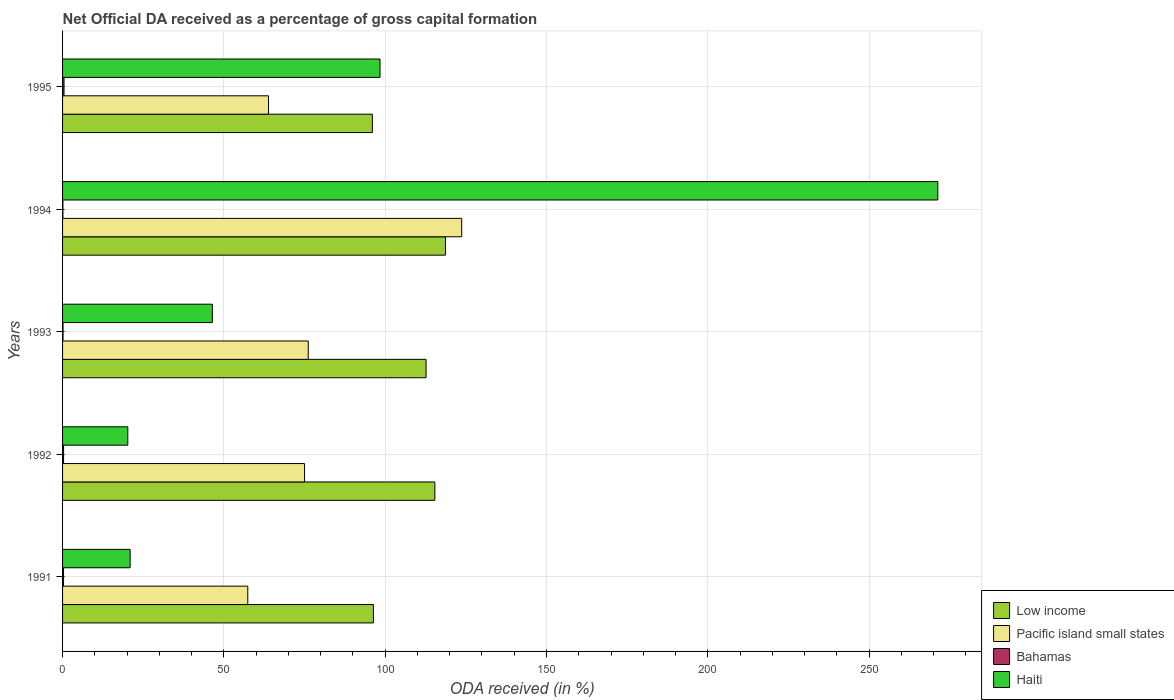How many different coloured bars are there?
Provide a short and direct response. 4. Are the number of bars per tick equal to the number of legend labels?
Your answer should be compact. Yes. How many bars are there on the 1st tick from the top?
Provide a succinct answer. 4. What is the label of the 5th group of bars from the top?
Offer a terse response. 1991. In how many cases, is the number of bars for a given year not equal to the number of legend labels?
Provide a succinct answer. 0. What is the net ODA received in Haiti in 1994?
Provide a succinct answer. 271.29. Across all years, what is the maximum net ODA received in Bahamas?
Your answer should be very brief. 0.45. Across all years, what is the minimum net ODA received in Low income?
Keep it short and to the point. 96.03. In which year was the net ODA received in Bahamas maximum?
Your response must be concise. 1995. What is the total net ODA received in Pacific island small states in the graph?
Provide a short and direct response. 396.11. What is the difference between the net ODA received in Bahamas in 1991 and that in 1992?
Provide a succinct answer. -0.01. What is the difference between the net ODA received in Low income in 1993 and the net ODA received in Haiti in 1995?
Ensure brevity in your answer.  14.27. What is the average net ODA received in Haiti per year?
Make the answer very short. 91.46. In the year 1993, what is the difference between the net ODA received in Low income and net ODA received in Bahamas?
Make the answer very short. 112.53. In how many years, is the net ODA received in Haiti greater than 100 %?
Keep it short and to the point. 1. What is the ratio of the net ODA received in Pacific island small states in 1993 to that in 1994?
Give a very brief answer. 0.62. What is the difference between the highest and the second highest net ODA received in Haiti?
Provide a succinct answer. 172.9. What is the difference between the highest and the lowest net ODA received in Low income?
Your answer should be very brief. 22.66. In how many years, is the net ODA received in Pacific island small states greater than the average net ODA received in Pacific island small states taken over all years?
Provide a short and direct response. 1. What does the 4th bar from the top in 1992 represents?
Keep it short and to the point. Low income. What does the 3rd bar from the bottom in 1991 represents?
Ensure brevity in your answer.  Bahamas. How many bars are there?
Your answer should be very brief. 20. How many years are there in the graph?
Your answer should be compact. 5. What is the difference between two consecutive major ticks on the X-axis?
Your answer should be very brief. 50. Are the values on the major ticks of X-axis written in scientific E-notation?
Offer a terse response. No. How many legend labels are there?
Keep it short and to the point. 4. How are the legend labels stacked?
Your response must be concise. Vertical. What is the title of the graph?
Provide a short and direct response. Net Official DA received as a percentage of gross capital formation. What is the label or title of the X-axis?
Your answer should be compact. ODA received (in %). What is the label or title of the Y-axis?
Give a very brief answer. Years. What is the ODA received (in %) in Low income in 1991?
Offer a terse response. 96.34. What is the ODA received (in %) in Pacific island small states in 1991?
Ensure brevity in your answer.  57.41. What is the ODA received (in %) in Bahamas in 1991?
Ensure brevity in your answer.  0.3. What is the ODA received (in %) of Haiti in 1991?
Provide a short and direct response. 20.95. What is the ODA received (in %) of Low income in 1992?
Offer a very short reply. 115.4. What is the ODA received (in %) in Pacific island small states in 1992?
Provide a short and direct response. 75. What is the ODA received (in %) in Bahamas in 1992?
Your answer should be compact. 0.31. What is the ODA received (in %) in Haiti in 1992?
Offer a terse response. 20.23. What is the ODA received (in %) in Low income in 1993?
Offer a very short reply. 112.67. What is the ODA received (in %) in Pacific island small states in 1993?
Keep it short and to the point. 76.15. What is the ODA received (in %) of Bahamas in 1993?
Your answer should be very brief. 0.14. What is the ODA received (in %) of Haiti in 1993?
Ensure brevity in your answer.  46.42. What is the ODA received (in %) in Low income in 1994?
Offer a terse response. 118.68. What is the ODA received (in %) of Pacific island small states in 1994?
Your answer should be very brief. 123.71. What is the ODA received (in %) in Bahamas in 1994?
Provide a succinct answer. 0.1. What is the ODA received (in %) of Haiti in 1994?
Your answer should be very brief. 271.29. What is the ODA received (in %) in Low income in 1995?
Your answer should be very brief. 96.03. What is the ODA received (in %) in Pacific island small states in 1995?
Ensure brevity in your answer.  63.84. What is the ODA received (in %) of Bahamas in 1995?
Your response must be concise. 0.45. What is the ODA received (in %) of Haiti in 1995?
Your response must be concise. 98.4. Across all years, what is the maximum ODA received (in %) in Low income?
Provide a succinct answer. 118.68. Across all years, what is the maximum ODA received (in %) of Pacific island small states?
Your answer should be compact. 123.71. Across all years, what is the maximum ODA received (in %) in Bahamas?
Provide a short and direct response. 0.45. Across all years, what is the maximum ODA received (in %) of Haiti?
Keep it short and to the point. 271.29. Across all years, what is the minimum ODA received (in %) of Low income?
Your response must be concise. 96.03. Across all years, what is the minimum ODA received (in %) in Pacific island small states?
Give a very brief answer. 57.41. Across all years, what is the minimum ODA received (in %) in Bahamas?
Your answer should be compact. 0.1. Across all years, what is the minimum ODA received (in %) in Haiti?
Provide a short and direct response. 20.23. What is the total ODA received (in %) in Low income in the graph?
Provide a short and direct response. 539.12. What is the total ODA received (in %) in Pacific island small states in the graph?
Provide a succinct answer. 396.11. What is the total ODA received (in %) of Bahamas in the graph?
Give a very brief answer. 1.31. What is the total ODA received (in %) of Haiti in the graph?
Your answer should be compact. 457.28. What is the difference between the ODA received (in %) of Low income in 1991 and that in 1992?
Provide a short and direct response. -19.05. What is the difference between the ODA received (in %) of Pacific island small states in 1991 and that in 1992?
Give a very brief answer. -17.59. What is the difference between the ODA received (in %) of Bahamas in 1991 and that in 1992?
Offer a terse response. -0.01. What is the difference between the ODA received (in %) of Haiti in 1991 and that in 1992?
Make the answer very short. 0.72. What is the difference between the ODA received (in %) of Low income in 1991 and that in 1993?
Offer a very short reply. -16.33. What is the difference between the ODA received (in %) in Pacific island small states in 1991 and that in 1993?
Give a very brief answer. -18.74. What is the difference between the ODA received (in %) of Bahamas in 1991 and that in 1993?
Provide a succinct answer. 0.16. What is the difference between the ODA received (in %) of Haiti in 1991 and that in 1993?
Your response must be concise. -25.48. What is the difference between the ODA received (in %) of Low income in 1991 and that in 1994?
Your response must be concise. -22.34. What is the difference between the ODA received (in %) of Pacific island small states in 1991 and that in 1994?
Make the answer very short. -66.3. What is the difference between the ODA received (in %) of Bahamas in 1991 and that in 1994?
Your answer should be very brief. 0.2. What is the difference between the ODA received (in %) of Haiti in 1991 and that in 1994?
Offer a very short reply. -250.35. What is the difference between the ODA received (in %) of Low income in 1991 and that in 1995?
Offer a very short reply. 0.32. What is the difference between the ODA received (in %) of Pacific island small states in 1991 and that in 1995?
Offer a terse response. -6.43. What is the difference between the ODA received (in %) in Bahamas in 1991 and that in 1995?
Provide a short and direct response. -0.15. What is the difference between the ODA received (in %) of Haiti in 1991 and that in 1995?
Give a very brief answer. -77.45. What is the difference between the ODA received (in %) of Low income in 1992 and that in 1993?
Offer a very short reply. 2.72. What is the difference between the ODA received (in %) in Pacific island small states in 1992 and that in 1993?
Provide a succinct answer. -1.15. What is the difference between the ODA received (in %) in Bahamas in 1992 and that in 1993?
Provide a succinct answer. 0.17. What is the difference between the ODA received (in %) of Haiti in 1992 and that in 1993?
Provide a short and direct response. -26.2. What is the difference between the ODA received (in %) in Low income in 1992 and that in 1994?
Offer a terse response. -3.29. What is the difference between the ODA received (in %) in Pacific island small states in 1992 and that in 1994?
Keep it short and to the point. -48.71. What is the difference between the ODA received (in %) in Bahamas in 1992 and that in 1994?
Ensure brevity in your answer.  0.21. What is the difference between the ODA received (in %) of Haiti in 1992 and that in 1994?
Your answer should be very brief. -251.07. What is the difference between the ODA received (in %) of Low income in 1992 and that in 1995?
Offer a terse response. 19.37. What is the difference between the ODA received (in %) in Pacific island small states in 1992 and that in 1995?
Ensure brevity in your answer.  11.16. What is the difference between the ODA received (in %) of Bahamas in 1992 and that in 1995?
Offer a terse response. -0.14. What is the difference between the ODA received (in %) in Haiti in 1992 and that in 1995?
Keep it short and to the point. -78.17. What is the difference between the ODA received (in %) of Low income in 1993 and that in 1994?
Your answer should be very brief. -6.01. What is the difference between the ODA received (in %) in Pacific island small states in 1993 and that in 1994?
Make the answer very short. -47.56. What is the difference between the ODA received (in %) of Bahamas in 1993 and that in 1994?
Offer a terse response. 0.04. What is the difference between the ODA received (in %) of Haiti in 1993 and that in 1994?
Provide a succinct answer. -224.87. What is the difference between the ODA received (in %) in Low income in 1993 and that in 1995?
Your answer should be very brief. 16.64. What is the difference between the ODA received (in %) of Pacific island small states in 1993 and that in 1995?
Make the answer very short. 12.31. What is the difference between the ODA received (in %) of Bahamas in 1993 and that in 1995?
Give a very brief answer. -0.31. What is the difference between the ODA received (in %) of Haiti in 1993 and that in 1995?
Keep it short and to the point. -51.98. What is the difference between the ODA received (in %) of Low income in 1994 and that in 1995?
Keep it short and to the point. 22.66. What is the difference between the ODA received (in %) in Pacific island small states in 1994 and that in 1995?
Offer a very short reply. 59.87. What is the difference between the ODA received (in %) in Bahamas in 1994 and that in 1995?
Offer a very short reply. -0.35. What is the difference between the ODA received (in %) of Haiti in 1994 and that in 1995?
Give a very brief answer. 172.9. What is the difference between the ODA received (in %) of Low income in 1991 and the ODA received (in %) of Pacific island small states in 1992?
Your answer should be very brief. 21.34. What is the difference between the ODA received (in %) of Low income in 1991 and the ODA received (in %) of Bahamas in 1992?
Your response must be concise. 96.03. What is the difference between the ODA received (in %) of Low income in 1991 and the ODA received (in %) of Haiti in 1992?
Give a very brief answer. 76.12. What is the difference between the ODA received (in %) of Pacific island small states in 1991 and the ODA received (in %) of Bahamas in 1992?
Your response must be concise. 57.1. What is the difference between the ODA received (in %) in Pacific island small states in 1991 and the ODA received (in %) in Haiti in 1992?
Give a very brief answer. 37.18. What is the difference between the ODA received (in %) of Bahamas in 1991 and the ODA received (in %) of Haiti in 1992?
Offer a very short reply. -19.92. What is the difference between the ODA received (in %) in Low income in 1991 and the ODA received (in %) in Pacific island small states in 1993?
Give a very brief answer. 20.2. What is the difference between the ODA received (in %) of Low income in 1991 and the ODA received (in %) of Bahamas in 1993?
Provide a short and direct response. 96.2. What is the difference between the ODA received (in %) in Low income in 1991 and the ODA received (in %) in Haiti in 1993?
Offer a very short reply. 49.92. What is the difference between the ODA received (in %) in Pacific island small states in 1991 and the ODA received (in %) in Bahamas in 1993?
Make the answer very short. 57.27. What is the difference between the ODA received (in %) of Pacific island small states in 1991 and the ODA received (in %) of Haiti in 1993?
Your answer should be compact. 10.99. What is the difference between the ODA received (in %) in Bahamas in 1991 and the ODA received (in %) in Haiti in 1993?
Make the answer very short. -46.12. What is the difference between the ODA received (in %) of Low income in 1991 and the ODA received (in %) of Pacific island small states in 1994?
Give a very brief answer. -27.37. What is the difference between the ODA received (in %) of Low income in 1991 and the ODA received (in %) of Bahamas in 1994?
Your answer should be compact. 96.24. What is the difference between the ODA received (in %) of Low income in 1991 and the ODA received (in %) of Haiti in 1994?
Your answer should be compact. -174.95. What is the difference between the ODA received (in %) of Pacific island small states in 1991 and the ODA received (in %) of Bahamas in 1994?
Make the answer very short. 57.31. What is the difference between the ODA received (in %) in Pacific island small states in 1991 and the ODA received (in %) in Haiti in 1994?
Provide a succinct answer. -213.88. What is the difference between the ODA received (in %) of Bahamas in 1991 and the ODA received (in %) of Haiti in 1994?
Your response must be concise. -270.99. What is the difference between the ODA received (in %) of Low income in 1991 and the ODA received (in %) of Pacific island small states in 1995?
Keep it short and to the point. 32.5. What is the difference between the ODA received (in %) of Low income in 1991 and the ODA received (in %) of Bahamas in 1995?
Give a very brief answer. 95.89. What is the difference between the ODA received (in %) of Low income in 1991 and the ODA received (in %) of Haiti in 1995?
Keep it short and to the point. -2.06. What is the difference between the ODA received (in %) of Pacific island small states in 1991 and the ODA received (in %) of Bahamas in 1995?
Provide a short and direct response. 56.96. What is the difference between the ODA received (in %) of Pacific island small states in 1991 and the ODA received (in %) of Haiti in 1995?
Your answer should be compact. -40.99. What is the difference between the ODA received (in %) of Bahamas in 1991 and the ODA received (in %) of Haiti in 1995?
Keep it short and to the point. -98.1. What is the difference between the ODA received (in %) in Low income in 1992 and the ODA received (in %) in Pacific island small states in 1993?
Provide a succinct answer. 39.25. What is the difference between the ODA received (in %) of Low income in 1992 and the ODA received (in %) of Bahamas in 1993?
Offer a terse response. 115.25. What is the difference between the ODA received (in %) in Low income in 1992 and the ODA received (in %) in Haiti in 1993?
Provide a short and direct response. 68.97. What is the difference between the ODA received (in %) in Pacific island small states in 1992 and the ODA received (in %) in Bahamas in 1993?
Provide a succinct answer. 74.86. What is the difference between the ODA received (in %) of Pacific island small states in 1992 and the ODA received (in %) of Haiti in 1993?
Your answer should be very brief. 28.58. What is the difference between the ODA received (in %) in Bahamas in 1992 and the ODA received (in %) in Haiti in 1993?
Your response must be concise. -46.11. What is the difference between the ODA received (in %) of Low income in 1992 and the ODA received (in %) of Pacific island small states in 1994?
Offer a very short reply. -8.31. What is the difference between the ODA received (in %) in Low income in 1992 and the ODA received (in %) in Bahamas in 1994?
Offer a terse response. 115.29. What is the difference between the ODA received (in %) of Low income in 1992 and the ODA received (in %) of Haiti in 1994?
Offer a very short reply. -155.9. What is the difference between the ODA received (in %) in Pacific island small states in 1992 and the ODA received (in %) in Bahamas in 1994?
Offer a terse response. 74.9. What is the difference between the ODA received (in %) of Pacific island small states in 1992 and the ODA received (in %) of Haiti in 1994?
Your response must be concise. -196.29. What is the difference between the ODA received (in %) of Bahamas in 1992 and the ODA received (in %) of Haiti in 1994?
Provide a succinct answer. -270.98. What is the difference between the ODA received (in %) of Low income in 1992 and the ODA received (in %) of Pacific island small states in 1995?
Ensure brevity in your answer.  51.56. What is the difference between the ODA received (in %) of Low income in 1992 and the ODA received (in %) of Bahamas in 1995?
Ensure brevity in your answer.  114.95. What is the difference between the ODA received (in %) of Low income in 1992 and the ODA received (in %) of Haiti in 1995?
Your response must be concise. 17. What is the difference between the ODA received (in %) of Pacific island small states in 1992 and the ODA received (in %) of Bahamas in 1995?
Provide a succinct answer. 74.55. What is the difference between the ODA received (in %) of Pacific island small states in 1992 and the ODA received (in %) of Haiti in 1995?
Your response must be concise. -23.4. What is the difference between the ODA received (in %) in Bahamas in 1992 and the ODA received (in %) in Haiti in 1995?
Your answer should be compact. -98.09. What is the difference between the ODA received (in %) in Low income in 1993 and the ODA received (in %) in Pacific island small states in 1994?
Make the answer very short. -11.04. What is the difference between the ODA received (in %) in Low income in 1993 and the ODA received (in %) in Bahamas in 1994?
Ensure brevity in your answer.  112.57. What is the difference between the ODA received (in %) of Low income in 1993 and the ODA received (in %) of Haiti in 1994?
Ensure brevity in your answer.  -158.62. What is the difference between the ODA received (in %) of Pacific island small states in 1993 and the ODA received (in %) of Bahamas in 1994?
Your answer should be compact. 76.04. What is the difference between the ODA received (in %) of Pacific island small states in 1993 and the ODA received (in %) of Haiti in 1994?
Make the answer very short. -195.15. What is the difference between the ODA received (in %) in Bahamas in 1993 and the ODA received (in %) in Haiti in 1994?
Offer a terse response. -271.15. What is the difference between the ODA received (in %) in Low income in 1993 and the ODA received (in %) in Pacific island small states in 1995?
Your answer should be very brief. 48.83. What is the difference between the ODA received (in %) of Low income in 1993 and the ODA received (in %) of Bahamas in 1995?
Provide a short and direct response. 112.22. What is the difference between the ODA received (in %) in Low income in 1993 and the ODA received (in %) in Haiti in 1995?
Provide a succinct answer. 14.27. What is the difference between the ODA received (in %) in Pacific island small states in 1993 and the ODA received (in %) in Bahamas in 1995?
Make the answer very short. 75.7. What is the difference between the ODA received (in %) in Pacific island small states in 1993 and the ODA received (in %) in Haiti in 1995?
Your answer should be very brief. -22.25. What is the difference between the ODA received (in %) of Bahamas in 1993 and the ODA received (in %) of Haiti in 1995?
Provide a short and direct response. -98.25. What is the difference between the ODA received (in %) in Low income in 1994 and the ODA received (in %) in Pacific island small states in 1995?
Offer a very short reply. 54.84. What is the difference between the ODA received (in %) in Low income in 1994 and the ODA received (in %) in Bahamas in 1995?
Give a very brief answer. 118.23. What is the difference between the ODA received (in %) in Low income in 1994 and the ODA received (in %) in Haiti in 1995?
Offer a very short reply. 20.29. What is the difference between the ODA received (in %) in Pacific island small states in 1994 and the ODA received (in %) in Bahamas in 1995?
Keep it short and to the point. 123.26. What is the difference between the ODA received (in %) in Pacific island small states in 1994 and the ODA received (in %) in Haiti in 1995?
Offer a very short reply. 25.31. What is the difference between the ODA received (in %) of Bahamas in 1994 and the ODA received (in %) of Haiti in 1995?
Offer a terse response. -98.29. What is the average ODA received (in %) of Low income per year?
Your answer should be very brief. 107.82. What is the average ODA received (in %) in Pacific island small states per year?
Your answer should be compact. 79.22. What is the average ODA received (in %) of Bahamas per year?
Provide a succinct answer. 0.26. What is the average ODA received (in %) in Haiti per year?
Keep it short and to the point. 91.46. In the year 1991, what is the difference between the ODA received (in %) in Low income and ODA received (in %) in Pacific island small states?
Ensure brevity in your answer.  38.93. In the year 1991, what is the difference between the ODA received (in %) of Low income and ODA received (in %) of Bahamas?
Your answer should be compact. 96.04. In the year 1991, what is the difference between the ODA received (in %) in Low income and ODA received (in %) in Haiti?
Keep it short and to the point. 75.4. In the year 1991, what is the difference between the ODA received (in %) of Pacific island small states and ODA received (in %) of Bahamas?
Your response must be concise. 57.11. In the year 1991, what is the difference between the ODA received (in %) of Pacific island small states and ODA received (in %) of Haiti?
Provide a short and direct response. 36.46. In the year 1991, what is the difference between the ODA received (in %) in Bahamas and ODA received (in %) in Haiti?
Offer a terse response. -20.64. In the year 1992, what is the difference between the ODA received (in %) in Low income and ODA received (in %) in Pacific island small states?
Give a very brief answer. 40.39. In the year 1992, what is the difference between the ODA received (in %) of Low income and ODA received (in %) of Bahamas?
Give a very brief answer. 115.08. In the year 1992, what is the difference between the ODA received (in %) of Low income and ODA received (in %) of Haiti?
Your response must be concise. 95.17. In the year 1992, what is the difference between the ODA received (in %) of Pacific island small states and ODA received (in %) of Bahamas?
Your response must be concise. 74.69. In the year 1992, what is the difference between the ODA received (in %) in Pacific island small states and ODA received (in %) in Haiti?
Offer a very short reply. 54.78. In the year 1992, what is the difference between the ODA received (in %) of Bahamas and ODA received (in %) of Haiti?
Your answer should be very brief. -19.91. In the year 1993, what is the difference between the ODA received (in %) of Low income and ODA received (in %) of Pacific island small states?
Ensure brevity in your answer.  36.52. In the year 1993, what is the difference between the ODA received (in %) in Low income and ODA received (in %) in Bahamas?
Give a very brief answer. 112.53. In the year 1993, what is the difference between the ODA received (in %) of Low income and ODA received (in %) of Haiti?
Your answer should be very brief. 66.25. In the year 1993, what is the difference between the ODA received (in %) in Pacific island small states and ODA received (in %) in Bahamas?
Make the answer very short. 76. In the year 1993, what is the difference between the ODA received (in %) of Pacific island small states and ODA received (in %) of Haiti?
Offer a terse response. 29.72. In the year 1993, what is the difference between the ODA received (in %) in Bahamas and ODA received (in %) in Haiti?
Make the answer very short. -46.28. In the year 1994, what is the difference between the ODA received (in %) in Low income and ODA received (in %) in Pacific island small states?
Your answer should be compact. -5.03. In the year 1994, what is the difference between the ODA received (in %) in Low income and ODA received (in %) in Bahamas?
Offer a terse response. 118.58. In the year 1994, what is the difference between the ODA received (in %) in Low income and ODA received (in %) in Haiti?
Offer a very short reply. -152.61. In the year 1994, what is the difference between the ODA received (in %) of Pacific island small states and ODA received (in %) of Bahamas?
Give a very brief answer. 123.61. In the year 1994, what is the difference between the ODA received (in %) in Pacific island small states and ODA received (in %) in Haiti?
Provide a short and direct response. -147.58. In the year 1994, what is the difference between the ODA received (in %) in Bahamas and ODA received (in %) in Haiti?
Give a very brief answer. -271.19. In the year 1995, what is the difference between the ODA received (in %) in Low income and ODA received (in %) in Pacific island small states?
Provide a succinct answer. 32.19. In the year 1995, what is the difference between the ODA received (in %) of Low income and ODA received (in %) of Bahamas?
Keep it short and to the point. 95.58. In the year 1995, what is the difference between the ODA received (in %) in Low income and ODA received (in %) in Haiti?
Your response must be concise. -2.37. In the year 1995, what is the difference between the ODA received (in %) in Pacific island small states and ODA received (in %) in Bahamas?
Offer a very short reply. 63.39. In the year 1995, what is the difference between the ODA received (in %) in Pacific island small states and ODA received (in %) in Haiti?
Provide a short and direct response. -34.56. In the year 1995, what is the difference between the ODA received (in %) in Bahamas and ODA received (in %) in Haiti?
Make the answer very short. -97.95. What is the ratio of the ODA received (in %) of Low income in 1991 to that in 1992?
Offer a terse response. 0.83. What is the ratio of the ODA received (in %) of Pacific island small states in 1991 to that in 1992?
Offer a terse response. 0.77. What is the ratio of the ODA received (in %) of Bahamas in 1991 to that in 1992?
Give a very brief answer. 0.97. What is the ratio of the ODA received (in %) in Haiti in 1991 to that in 1992?
Your answer should be compact. 1.04. What is the ratio of the ODA received (in %) of Low income in 1991 to that in 1993?
Make the answer very short. 0.86. What is the ratio of the ODA received (in %) in Pacific island small states in 1991 to that in 1993?
Your answer should be very brief. 0.75. What is the ratio of the ODA received (in %) of Bahamas in 1991 to that in 1993?
Offer a very short reply. 2.12. What is the ratio of the ODA received (in %) in Haiti in 1991 to that in 1993?
Provide a short and direct response. 0.45. What is the ratio of the ODA received (in %) of Low income in 1991 to that in 1994?
Give a very brief answer. 0.81. What is the ratio of the ODA received (in %) of Pacific island small states in 1991 to that in 1994?
Your answer should be compact. 0.46. What is the ratio of the ODA received (in %) in Bahamas in 1991 to that in 1994?
Provide a short and direct response. 2.93. What is the ratio of the ODA received (in %) in Haiti in 1991 to that in 1994?
Ensure brevity in your answer.  0.08. What is the ratio of the ODA received (in %) of Low income in 1991 to that in 1995?
Your answer should be compact. 1. What is the ratio of the ODA received (in %) in Pacific island small states in 1991 to that in 1995?
Give a very brief answer. 0.9. What is the ratio of the ODA received (in %) of Bahamas in 1991 to that in 1995?
Offer a very short reply. 0.67. What is the ratio of the ODA received (in %) of Haiti in 1991 to that in 1995?
Provide a succinct answer. 0.21. What is the ratio of the ODA received (in %) in Low income in 1992 to that in 1993?
Offer a very short reply. 1.02. What is the ratio of the ODA received (in %) in Pacific island small states in 1992 to that in 1993?
Make the answer very short. 0.98. What is the ratio of the ODA received (in %) of Bahamas in 1992 to that in 1993?
Give a very brief answer. 2.18. What is the ratio of the ODA received (in %) in Haiti in 1992 to that in 1993?
Give a very brief answer. 0.44. What is the ratio of the ODA received (in %) of Low income in 1992 to that in 1994?
Make the answer very short. 0.97. What is the ratio of the ODA received (in %) in Pacific island small states in 1992 to that in 1994?
Ensure brevity in your answer.  0.61. What is the ratio of the ODA received (in %) of Bahamas in 1992 to that in 1994?
Give a very brief answer. 3.02. What is the ratio of the ODA received (in %) of Haiti in 1992 to that in 1994?
Your answer should be compact. 0.07. What is the ratio of the ODA received (in %) in Low income in 1992 to that in 1995?
Your response must be concise. 1.2. What is the ratio of the ODA received (in %) in Pacific island small states in 1992 to that in 1995?
Ensure brevity in your answer.  1.17. What is the ratio of the ODA received (in %) in Bahamas in 1992 to that in 1995?
Your answer should be very brief. 0.69. What is the ratio of the ODA received (in %) in Haiti in 1992 to that in 1995?
Keep it short and to the point. 0.21. What is the ratio of the ODA received (in %) of Low income in 1993 to that in 1994?
Ensure brevity in your answer.  0.95. What is the ratio of the ODA received (in %) in Pacific island small states in 1993 to that in 1994?
Your answer should be very brief. 0.62. What is the ratio of the ODA received (in %) in Bahamas in 1993 to that in 1994?
Your response must be concise. 1.38. What is the ratio of the ODA received (in %) of Haiti in 1993 to that in 1994?
Your answer should be compact. 0.17. What is the ratio of the ODA received (in %) in Low income in 1993 to that in 1995?
Provide a succinct answer. 1.17. What is the ratio of the ODA received (in %) of Pacific island small states in 1993 to that in 1995?
Keep it short and to the point. 1.19. What is the ratio of the ODA received (in %) of Bahamas in 1993 to that in 1995?
Give a very brief answer. 0.32. What is the ratio of the ODA received (in %) in Haiti in 1993 to that in 1995?
Make the answer very short. 0.47. What is the ratio of the ODA received (in %) in Low income in 1994 to that in 1995?
Provide a short and direct response. 1.24. What is the ratio of the ODA received (in %) of Pacific island small states in 1994 to that in 1995?
Your answer should be compact. 1.94. What is the ratio of the ODA received (in %) in Bahamas in 1994 to that in 1995?
Offer a terse response. 0.23. What is the ratio of the ODA received (in %) of Haiti in 1994 to that in 1995?
Ensure brevity in your answer.  2.76. What is the difference between the highest and the second highest ODA received (in %) of Low income?
Your answer should be compact. 3.29. What is the difference between the highest and the second highest ODA received (in %) in Pacific island small states?
Give a very brief answer. 47.56. What is the difference between the highest and the second highest ODA received (in %) in Bahamas?
Your answer should be compact. 0.14. What is the difference between the highest and the second highest ODA received (in %) of Haiti?
Provide a succinct answer. 172.9. What is the difference between the highest and the lowest ODA received (in %) in Low income?
Offer a very short reply. 22.66. What is the difference between the highest and the lowest ODA received (in %) of Pacific island small states?
Offer a terse response. 66.3. What is the difference between the highest and the lowest ODA received (in %) in Bahamas?
Keep it short and to the point. 0.35. What is the difference between the highest and the lowest ODA received (in %) of Haiti?
Provide a succinct answer. 251.07. 